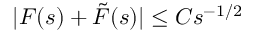<formula> <loc_0><loc_0><loc_500><loc_500>| F ( s ) + \tilde { F } ( s ) | \leq C s ^ { - 1 / 2 }</formula> 